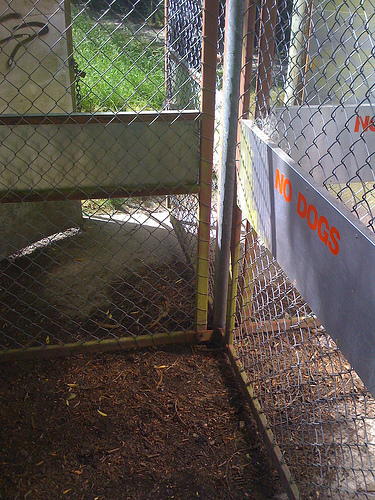<image>
Is there a sign on the fence? No. The sign is not positioned on the fence. They may be near each other, but the sign is not supported by or resting on top of the fence. 